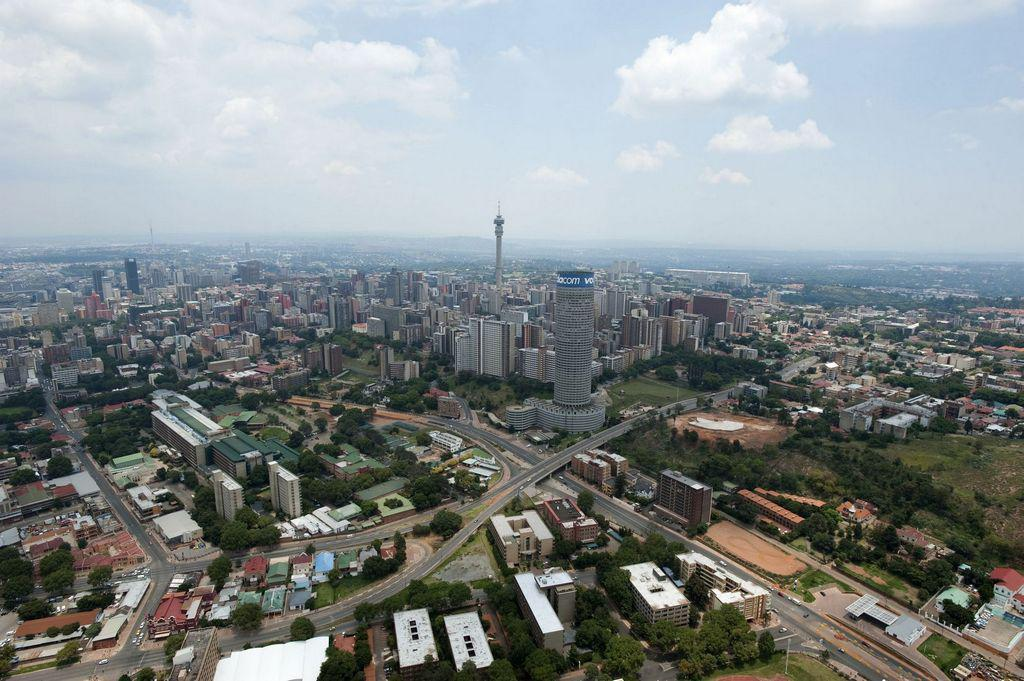What type of view is shown in the image? The image is a top view of a city. What structures can be seen in the image? There are many buildings in the image. What can be seen between the buildings? There are roads visible in the image. What is visible above the city in the image? The sky is visible in the image, and clouds are present in the sky. What type of bun is being used to hold the city together in the image? There is no bun present in the image; it is a top view of a city with buildings, roads, sky, and clouds. 